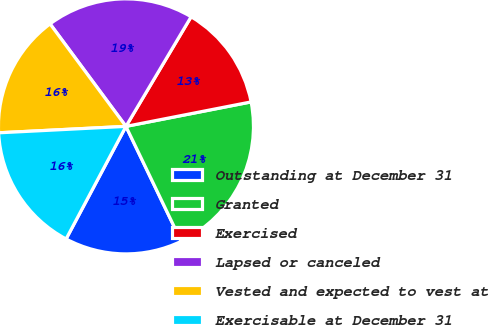<chart> <loc_0><loc_0><loc_500><loc_500><pie_chart><fcel>Outstanding at December 31<fcel>Granted<fcel>Exercised<fcel>Lapsed or canceled<fcel>Vested and expected to vest at<fcel>Exercisable at December 31<nl><fcel>14.91%<fcel>20.94%<fcel>13.39%<fcel>18.68%<fcel>15.66%<fcel>16.42%<nl></chart> 